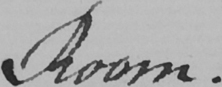What text is written in this handwritten line? Room . 